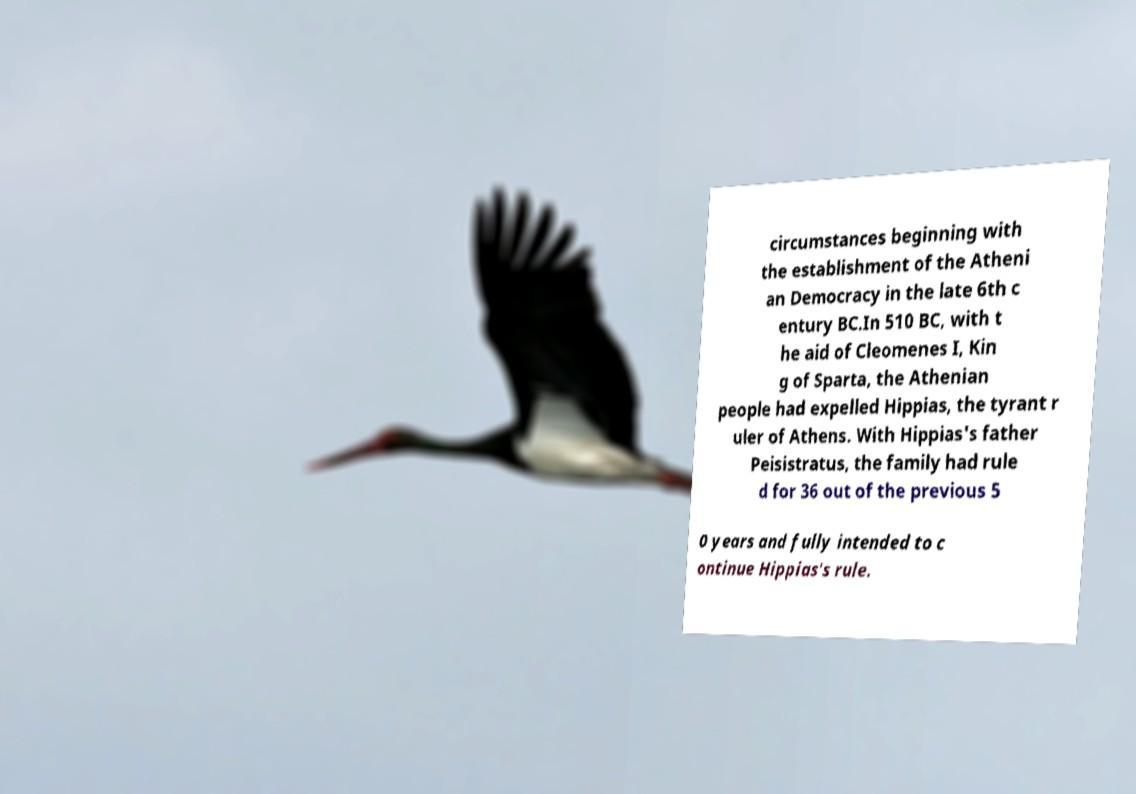Please read and relay the text visible in this image. What does it say? circumstances beginning with the establishment of the Atheni an Democracy in the late 6th c entury BC.In 510 BC, with t he aid of Cleomenes I, Kin g of Sparta, the Athenian people had expelled Hippias, the tyrant r uler of Athens. With Hippias's father Peisistratus, the family had rule d for 36 out of the previous 5 0 years and fully intended to c ontinue Hippias's rule. 